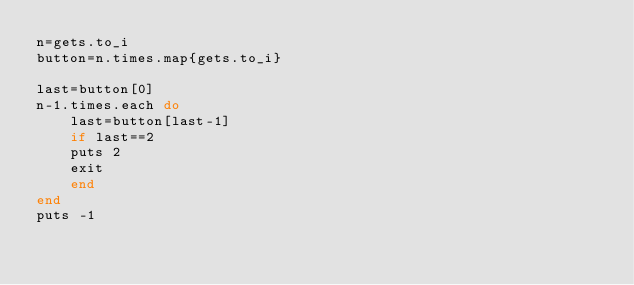<code> <loc_0><loc_0><loc_500><loc_500><_Ruby_>n=gets.to_i
button=n.times.map{gets.to_i}

last=button[0]
n-1.times.each do
    last=button[last-1]
    if last==2
    puts 2
    exit
    end
end
puts -1</code> 